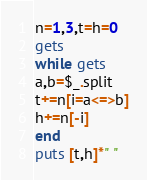<code> <loc_0><loc_0><loc_500><loc_500><_Ruby_>n=1,3,t=h=0
gets
while gets
a,b=$_.split
t+=n[i=a<=>b]
h+=n[-i]
end
puts [t,h]*" "</code> 